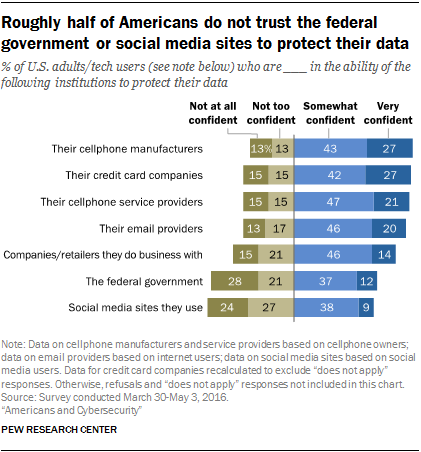Identify some key points in this picture. The light blue color bar denotes confidence at somewhat. The social media sites that are used are categorized into three groups: green, dark green, and blue/dark blue. The ratio between the number of users of these groups is approximately 2.157638889... 